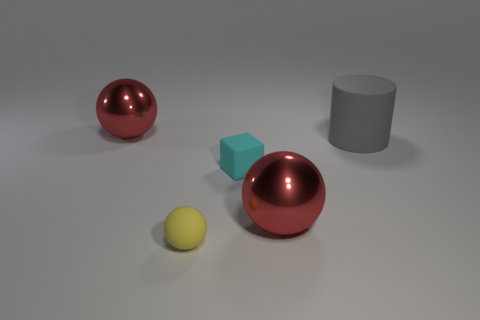Do the red ball behind the rubber cylinder and the cyan thing have the same size?
Your answer should be compact. No. There is a cyan thing that is the same size as the yellow matte ball; what material is it?
Keep it short and to the point. Rubber. How many other things are the same size as the cyan rubber block?
Make the answer very short. 1. What number of large balls are the same color as the small rubber sphere?
Give a very brief answer. 0. What is the shape of the small cyan rubber thing?
Keep it short and to the point. Cube. What color is the object that is behind the small cyan object and to the right of the tiny yellow rubber object?
Ensure brevity in your answer.  Gray. What material is the block?
Provide a short and direct response. Rubber. There is a big object in front of the big gray matte cylinder; what is its shape?
Make the answer very short. Sphere. There is a rubber object that is the same size as the cyan cube; what is its color?
Provide a short and direct response. Yellow. Do the red object that is behind the tiny cyan block and the yellow object have the same material?
Your response must be concise. No. 